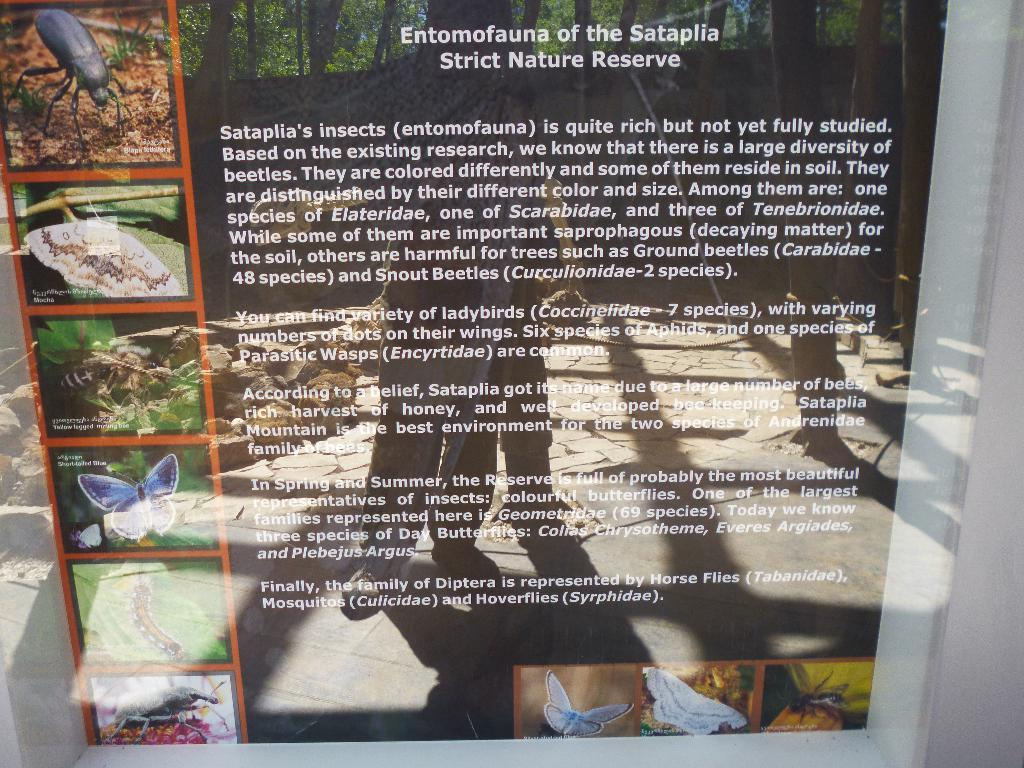What is present on the wall in the image? There is a poster on the wall in the image. What can be seen on the poster? The poster has images and text. How is the poster attached to the wall? The poster is attached to the wall. How many women are smashing peace signs in the image? There are no women or peace signs present in the image. 